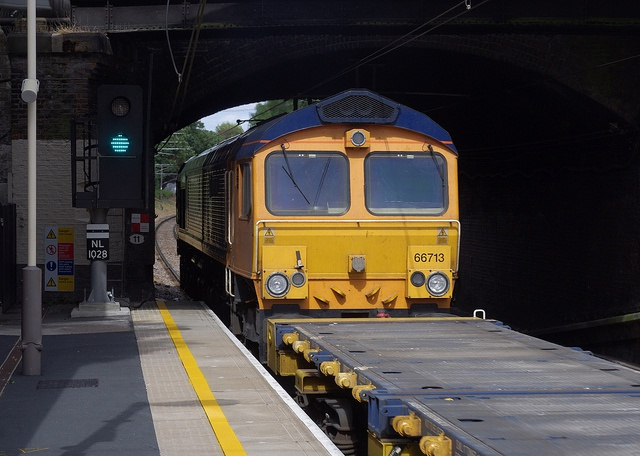Describe the objects in this image and their specific colors. I can see train in black, gray, and orange tones and traffic light in black, teal, and darkblue tones in this image. 